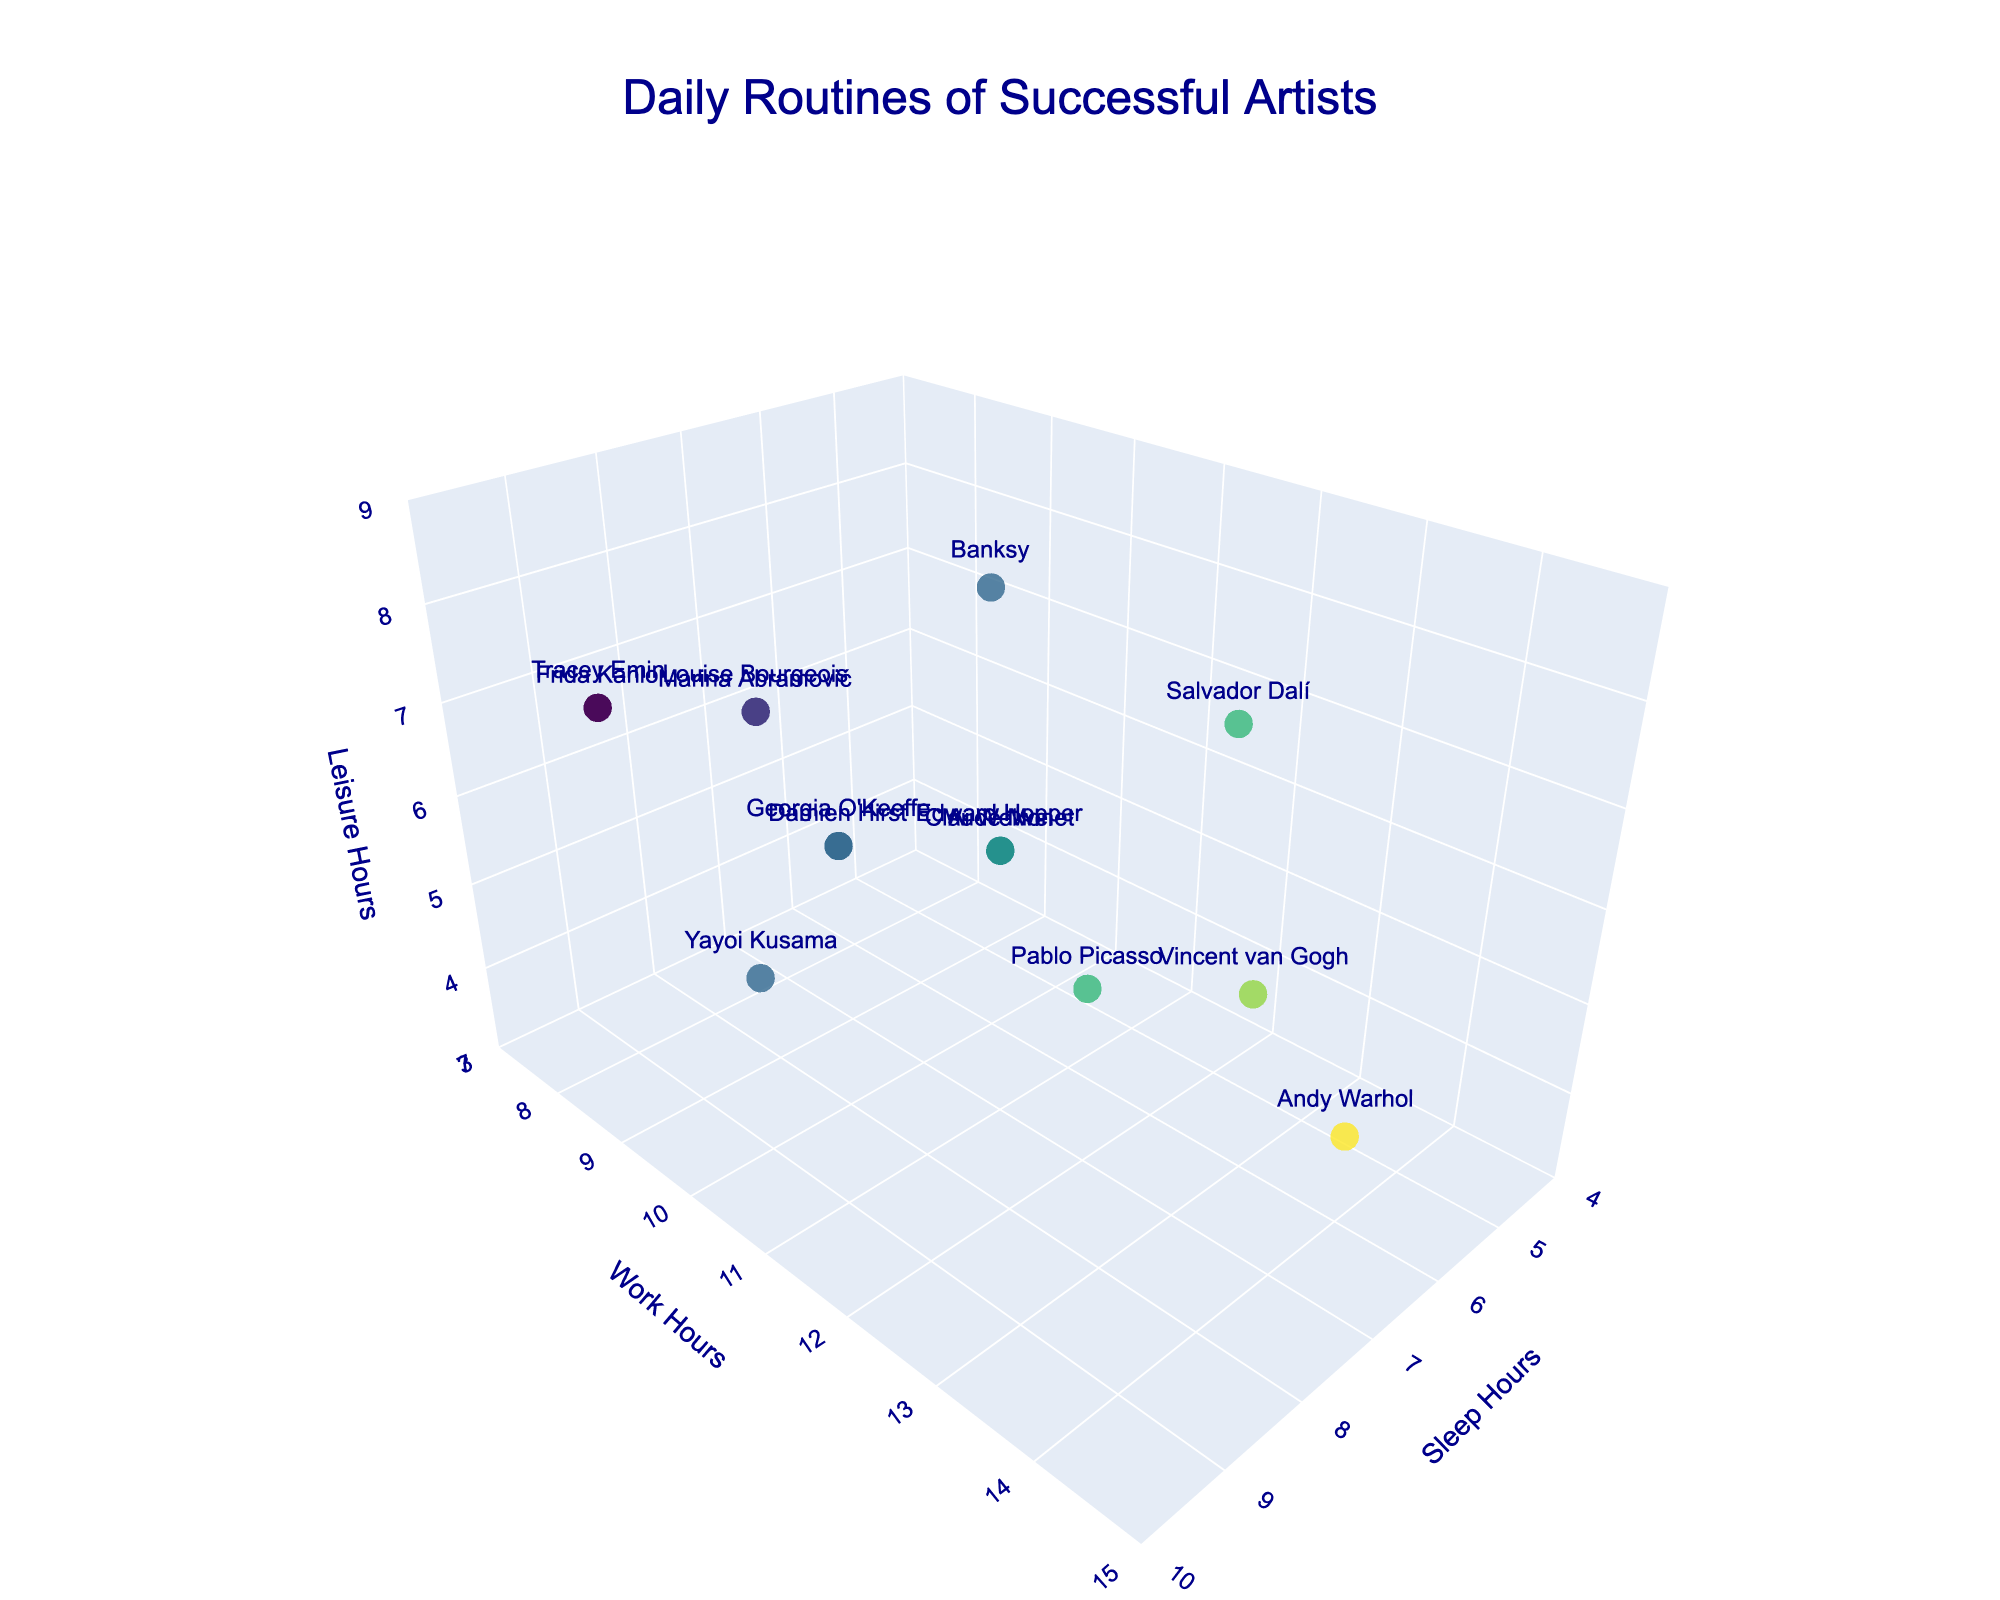What's the title of the plot? The title is provided at the top of the plot. Look at the top center to find the title.
Answer: Daily Routines of Successful Artists How many artists have their data points shown on this plot? Each marker represents an artist. Count the number of markers or the number of artists listed in the hover text. There are 15 artists.
Answer: 15 Which artist has the most sleep hours? Locate the artist with the highest value on the Sleep Hours axis. The artist with the maximum value is highlighted in the plot.
Answer: Frida Kahlo and Tracey Emin What are the leisure hours for Pablo Picasso? Check the hover text by Pablo Picasso's marker, where the artist's Daily Routine details are listed.
Answer: 5 Which artist works the most hours? Look for the artist whose data point is positioned highest along the Work Hours axis.
Answer: Andy Warhol What's the average sleep time of all artists? Add up all the sleep hours and divide by the number of artists. Calculating: (8+7+9+6+7+8+6+9+5+8+7+6+7+8+9)/15 = 7.27
Answer: 7.27 Who has more leisure hours, Vincent van Gogh or Banksy? Compare the Leisure Hours of both Vincent van Gogh (5 hours) and Banksy (8 hours) as indicated in the hover text.
Answer: Banksy Which two artists have equal sleep hours but differ in work hours by exactly 1 hour? Identify artists with the same Sleep Hours and calculate the difference in their Work Hours, looking for a difference of 1 hour in their positions on the plot.
Answer: Claude Monet and Ai Weiwei What's the sum of work hours and leisure hours for Georgia O'Keeffe? Add the Work Hours and Leisure Hours for Georgia O'Keeffe based on her data point details. Calculation: 10 (Work) + 6 (Leisure) = 16
Answer: 16 Which artist has the highest combined total of sleep, work, and leisure hours? Sum the Sleep, Work, and Leisure Hours for each artist and identify the highest total. Calculation: Andy Warhol: 6 + 14 + 4 = 24
Answer: Andy Warhol 